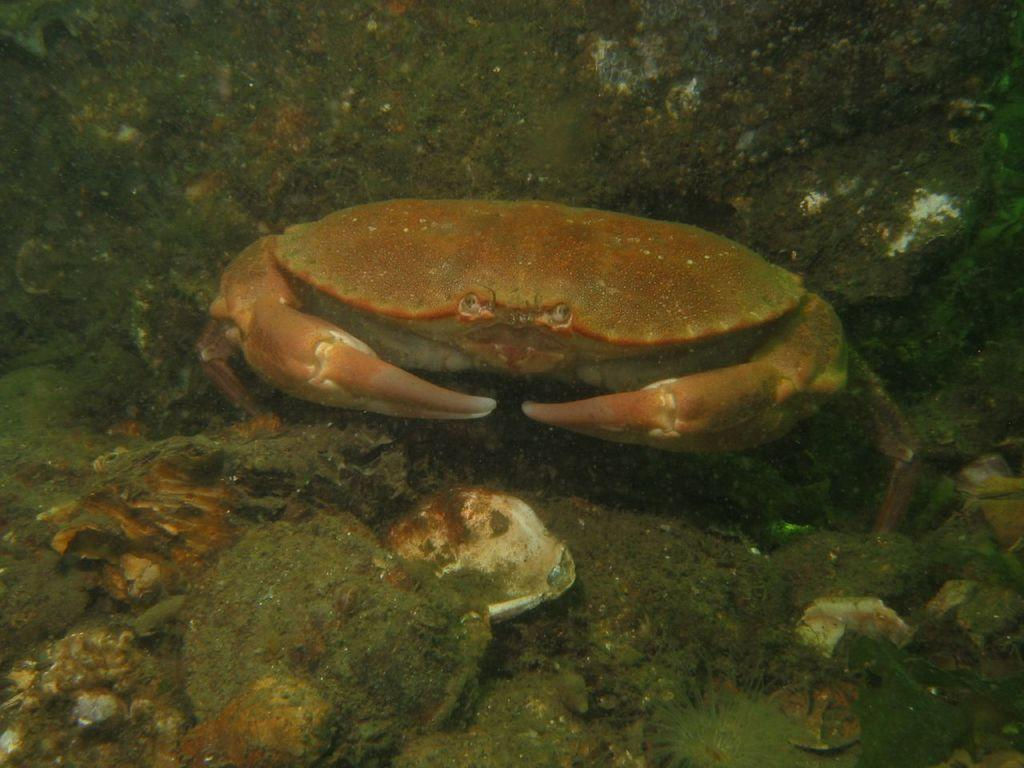What type of landscape is depicted in the image? There is a water body in the image. Can you describe the animals visible in the image? Unfortunately, the facts provided do not specify the type of animals present in the image. However, we can confirm that there are animals visible. What is the angle of the slope in the image? There is no slope present in the image; it features a water body and animals. What story is being told in the image? The image does not depict a story; it simply shows a water body and animals. 